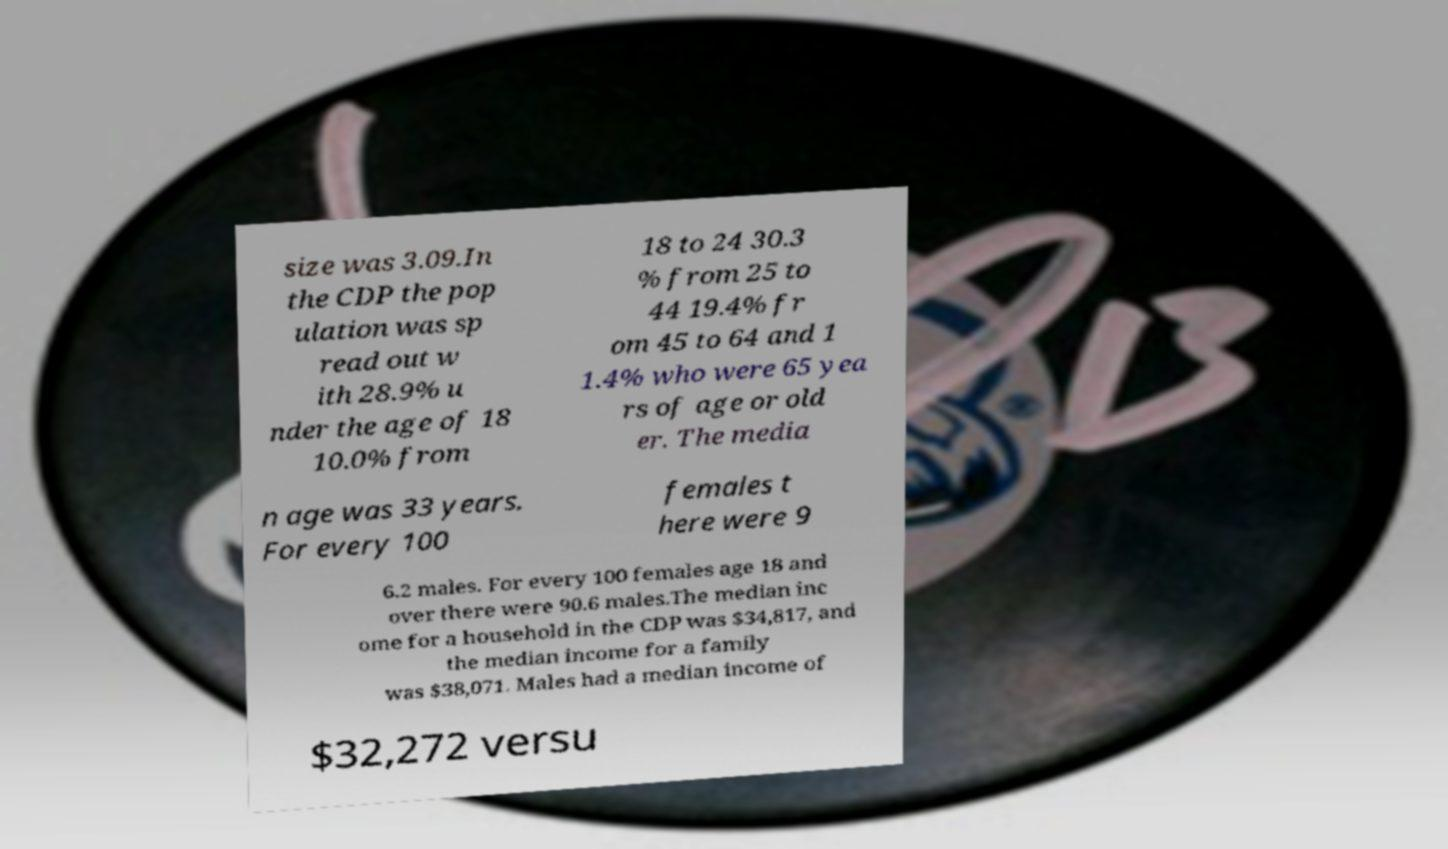I need the written content from this picture converted into text. Can you do that? size was 3.09.In the CDP the pop ulation was sp read out w ith 28.9% u nder the age of 18 10.0% from 18 to 24 30.3 % from 25 to 44 19.4% fr om 45 to 64 and 1 1.4% who were 65 yea rs of age or old er. The media n age was 33 years. For every 100 females t here were 9 6.2 males. For every 100 females age 18 and over there were 90.6 males.The median inc ome for a household in the CDP was $34,817, and the median income for a family was $38,071. Males had a median income of $32,272 versu 